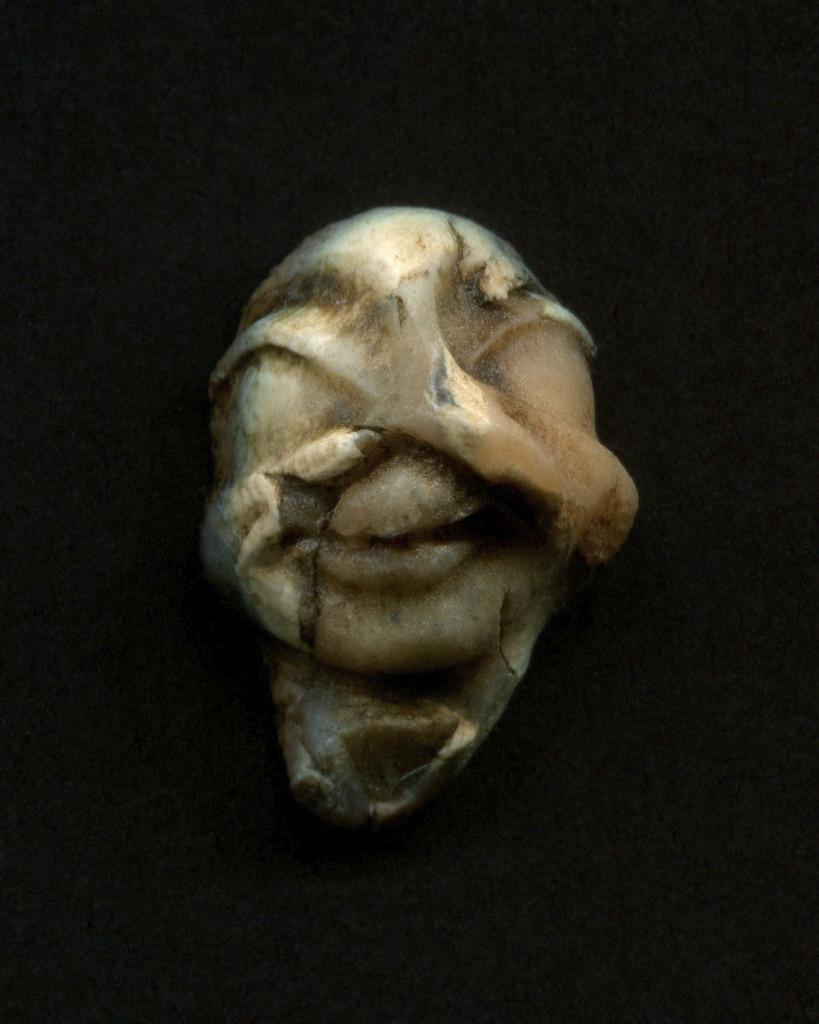How would you summarize this image in a sentence or two? In this image we can see an object which looks like a stone and in the background, the image is dark. 